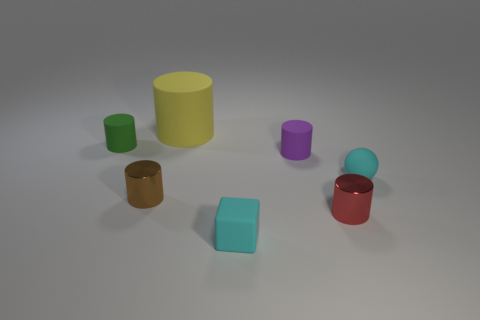Do the tiny block and the rubber sphere have the same color?
Ensure brevity in your answer.  Yes. There is a thing that is the same color as the tiny rubber ball; what shape is it?
Give a very brief answer. Cube. There is a matte cylinder in front of the green matte object that is on the left side of the red cylinder; what is its size?
Keep it short and to the point. Small. There is a object that is in front of the tiny purple cylinder and left of the small matte block; what size is it?
Make the answer very short. Small. Do the matte thing on the left side of the yellow cylinder and the big rubber object have the same shape?
Your answer should be very brief. Yes. Is the number of purple rubber objects left of the small cyan cube less than the number of red spheres?
Your answer should be compact. No. Are there any other balls that have the same color as the ball?
Offer a very short reply. No. There is a green thing; is its shape the same as the tiny red object that is left of the cyan matte sphere?
Provide a succinct answer. Yes. Are there any big yellow things made of the same material as the small red cylinder?
Keep it short and to the point. No. Are there any big cylinders that are to the right of the metal thing left of the small metallic thing on the right side of the small purple cylinder?
Offer a very short reply. Yes. 